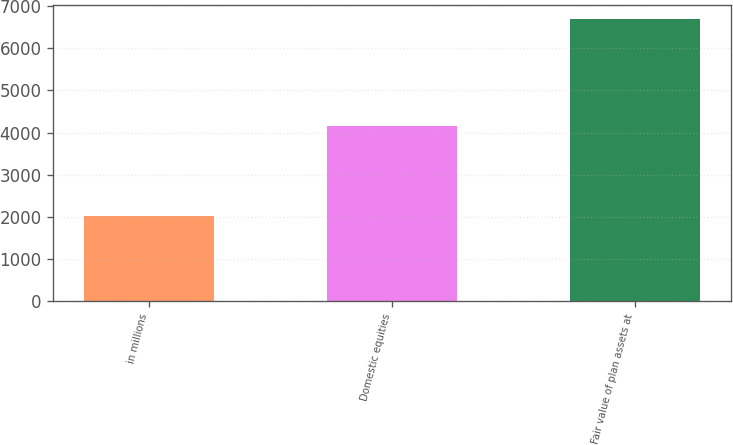<chart> <loc_0><loc_0><loc_500><loc_500><bar_chart><fcel>in millions<fcel>Domestic equities<fcel>Fair value of plan assets at<nl><fcel>2013<fcel>4163<fcel>6694<nl></chart> 